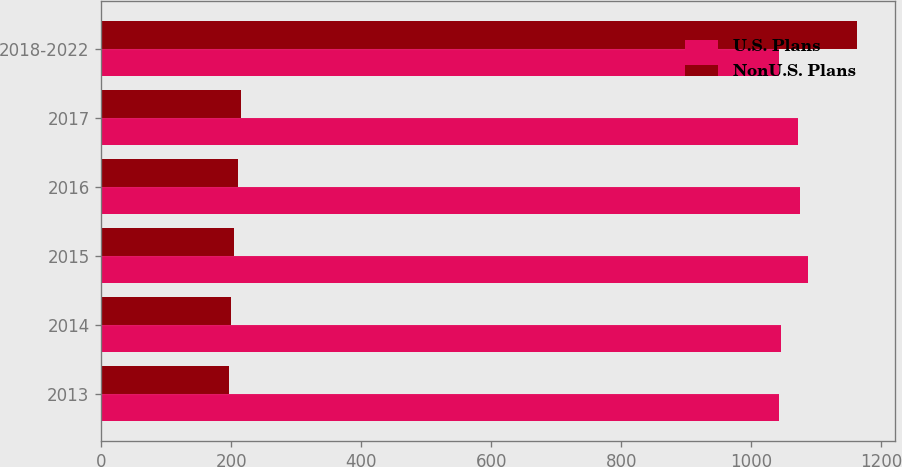Convert chart to OTSL. <chart><loc_0><loc_0><loc_500><loc_500><stacked_bar_chart><ecel><fcel>2013<fcel>2014<fcel>2015<fcel>2016<fcel>2017<fcel>2018-2022<nl><fcel>U.S. Plans<fcel>1043<fcel>1045<fcel>1087<fcel>1075<fcel>1071<fcel>1043<nl><fcel>NonU.S. Plans<fcel>196<fcel>200<fcel>205<fcel>210<fcel>215<fcel>1162<nl></chart> 